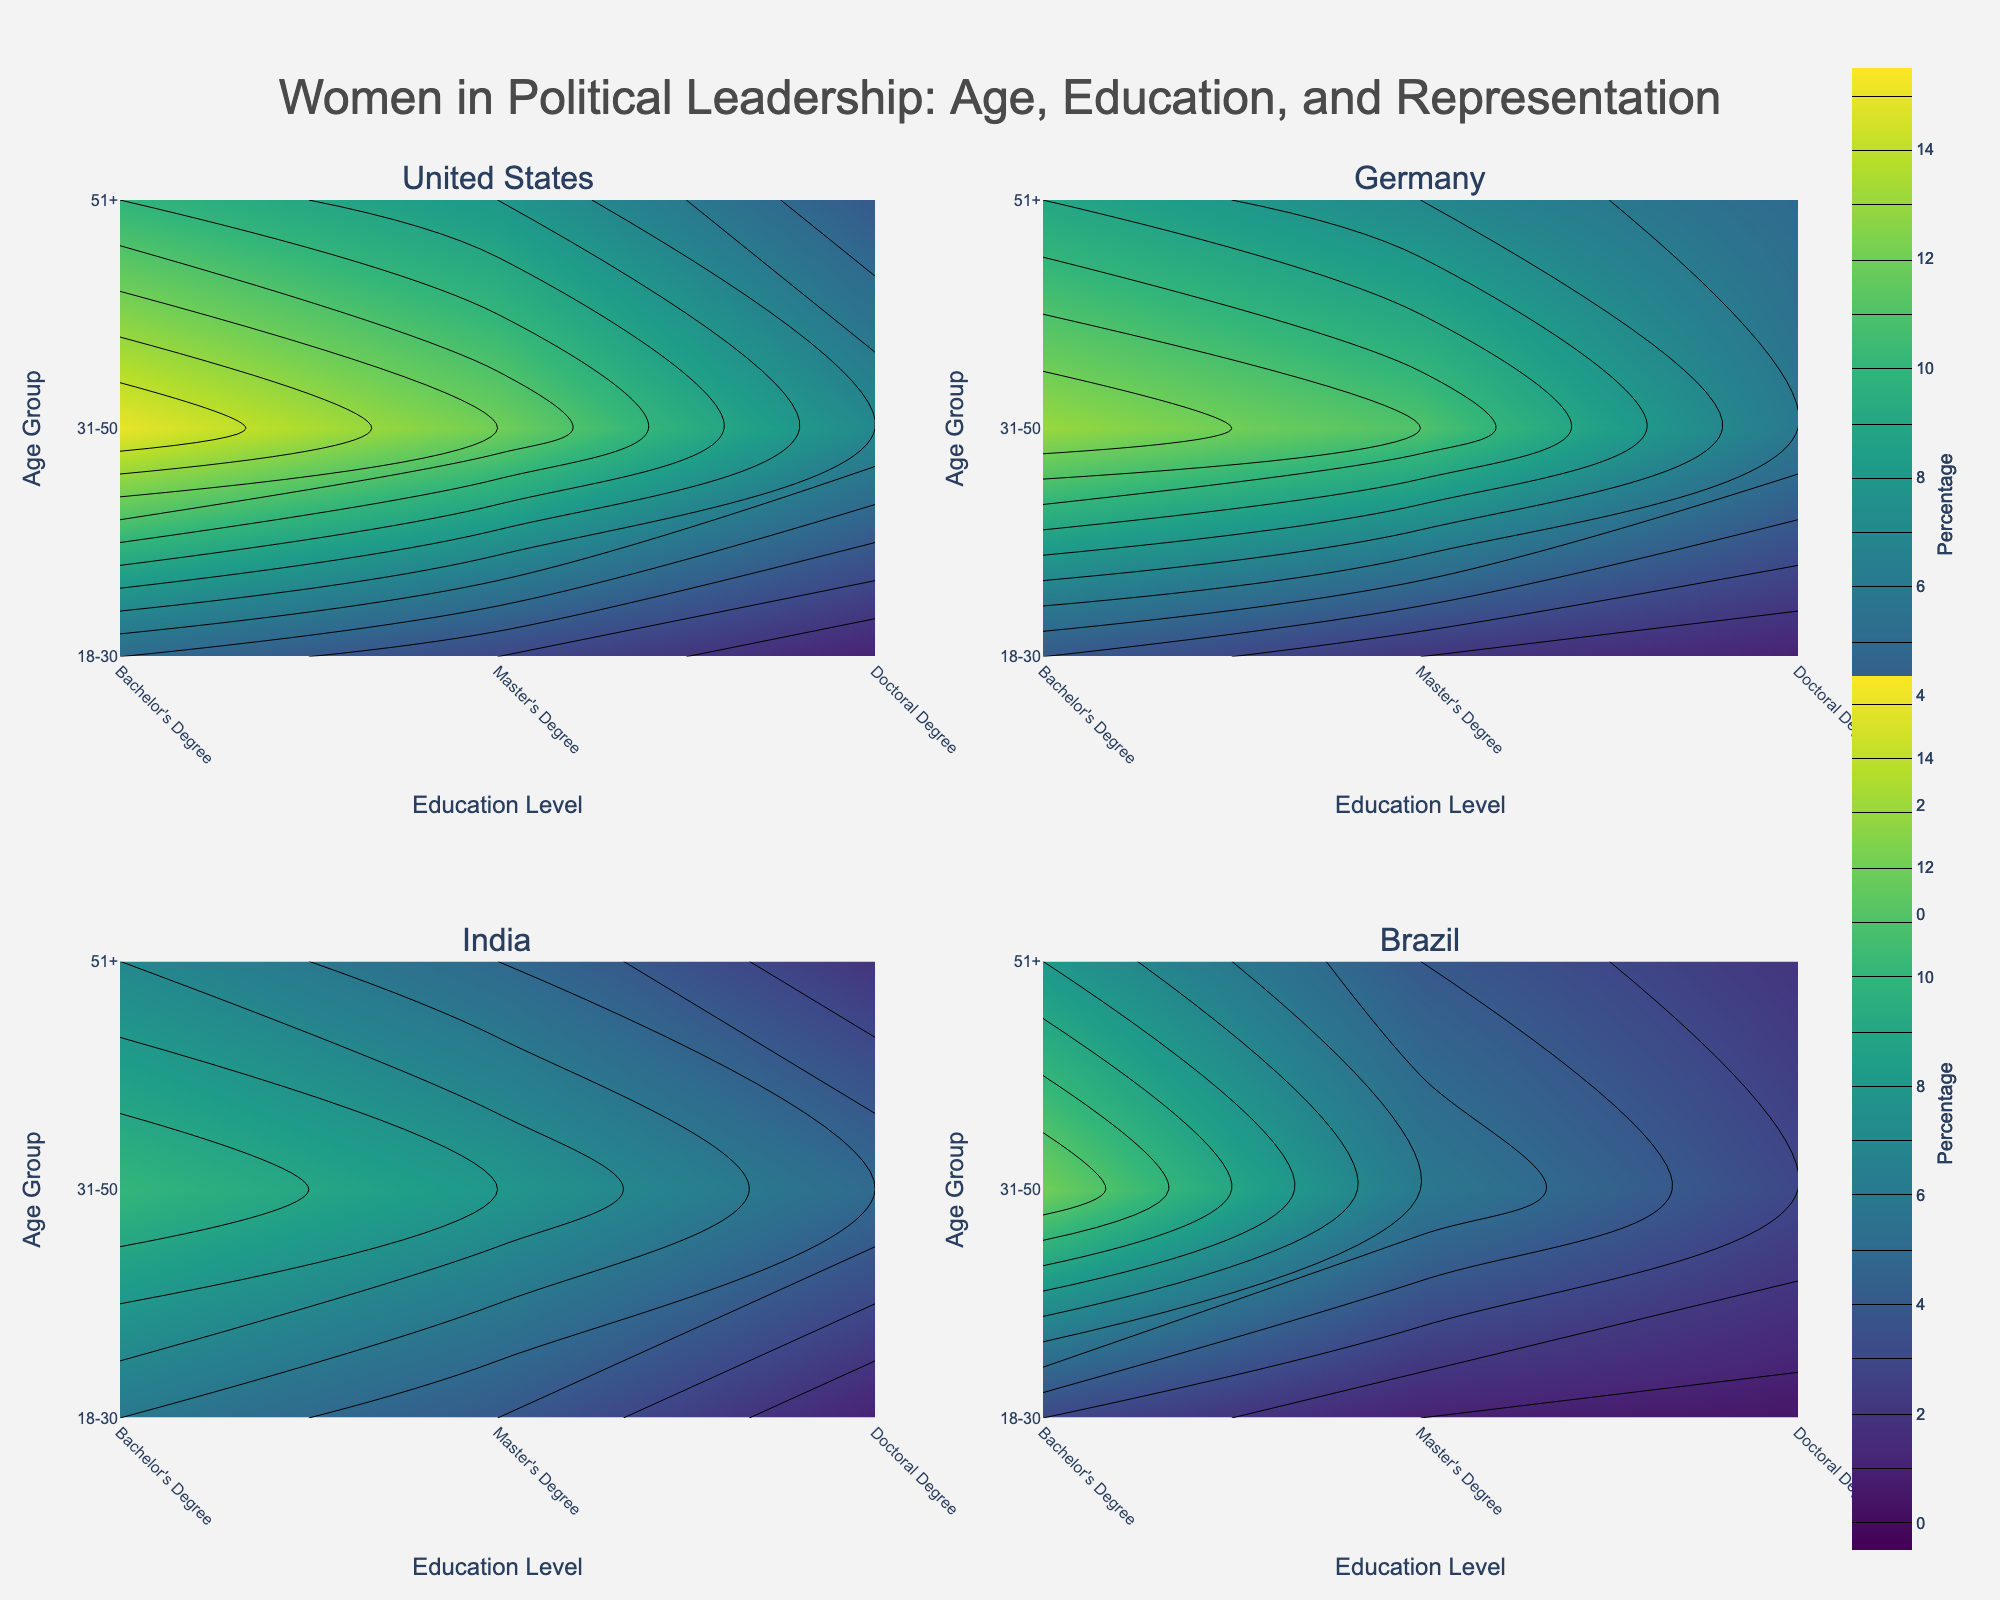What is the title of the figure? The title of the figure is displayed at the top of the image and it reads "Women in Political Leadership: Age, Education, and Representation."
Answer: Women in Political Leadership: Age, Education, and Representation What are the axes labels for the subplots? The x-axis is labeled "Education Level," and the y-axis is labeled "Age Group." These labels are uniform across all subplots.
Answer: Education Level (x-axis), Age Group (y-axis) Which country shows the highest percentage of women leaders with Bachelor's Degrees in the 31-50 age group? In the subplot for the United States, the percentage of women leaders with Bachelor's Degrees in the 31-50 age group is 15%. This is the highest value among all countries in this category.
Answer: United States Compare the percentage of women leaders with Doctoral Degrees in the 51+ age group between Germany and India. In the subplots, Germany has a 5% representation of women leaders with Doctoral Degrees in the 51+ age group compared to India's 2%. Germany has a higher percentage.
Answer: Germany Which age group generally has the highest percentage of women leaders across all countries? The age group 31-50 generally has the highest percentage of women leaders across all countries as indicated by the contour plots showing higher values in this category.
Answer: 31-50 What is the percentage difference in women leaders with Master's Degrees between the 18-30 and 31-50 age groups in Brazil? In the Brazil subplot, the percentage of women leaders with Master's Degrees is 1% for the 18-30 age group and 6% for the 31-50 age group. The difference is 6% - 1% = 5%.
Answer: 5% In which education level does India show equal representation of women leaders in both the 31-50 and 51+ age groups? In the subplot for India, women leaders with Bachelor's Degrees are represented equally in both the 31-50 and 51+ age groups with percentages of 10% and 7% respectively. Also, with Master's Degrees in the 31-50 and 51+ age groups, both have 8%.
Answer: Master's Degrees What are the contour colors indicating the highest representation levels? The highest representation levels are indicated by the darkest colors in the Viridis colorscale.
Answer: Darkest colors Is there any age group in the United States subplot where women with Doctoral Degrees have a representation of exactly 1%? Yes, in the United States subplot, the 18-30 age group shows a 1% representation for women with Doctoral Degrees.
Answer: Yes 